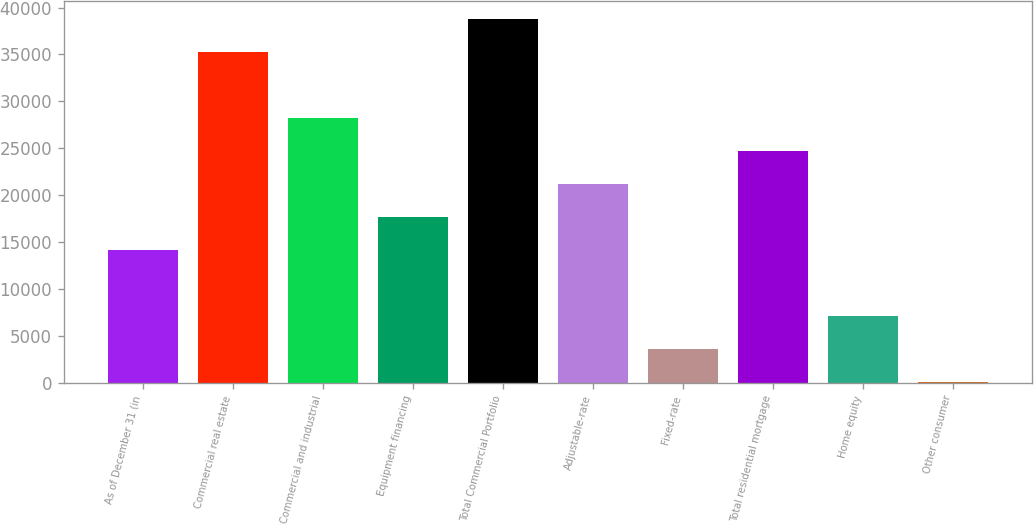Convert chart. <chart><loc_0><loc_0><loc_500><loc_500><bar_chart><fcel>As of December 31 (in<fcel>Commercial real estate<fcel>Commercial and industrial<fcel>Equipment financing<fcel>Total Commercial Portfolio<fcel>Adjustable-rate<fcel>Fixed-rate<fcel>Total residential mortgage<fcel>Home equity<fcel>Other consumer<nl><fcel>14124.8<fcel>35241.4<fcel>28202.5<fcel>17644.2<fcel>38760.8<fcel>21163.6<fcel>3566.44<fcel>24683.1<fcel>7085.88<fcel>47<nl></chart> 